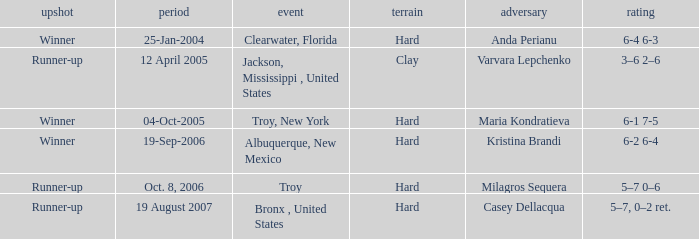What is the final score of the tournament played in Clearwater, Florida? 6-4 6-3. 